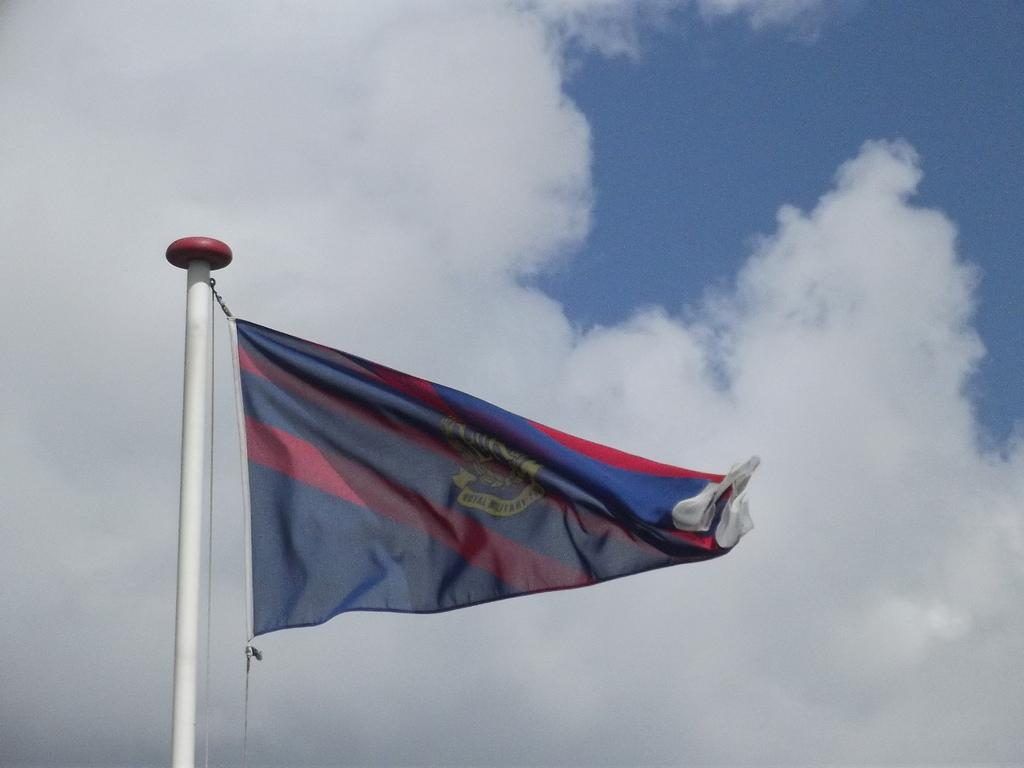What is located on the left side of the image? There is a flag on the left side of the image. How is the flag attached to the pole? The flag is attached to a thread, which is attached to a white color pole. What can be seen in the background of the image? There are clouds in the background of the image. What color is the sky in the image? The sky is blue in the image. What statement does the class make about the fictional character in the image? There is no class or fictional character present in the image; it features a flag attached to a pole with clouds and a blue sky in the background. 